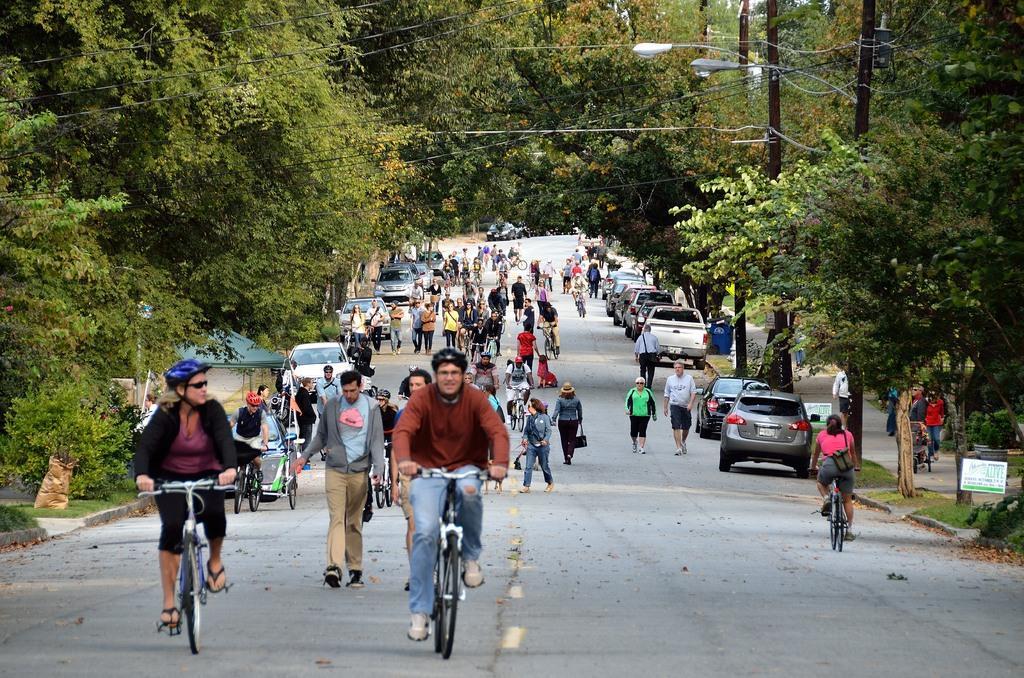Please provide a concise description of this image. In this image there are a few people walking and cycling on the road, and there are a few vehicles parked on the road, besides the road on the pavement there are a few people walking and there are some sign boards and trash cans, in the background of the image there are trees and electric poles with cables and lamps on it. 